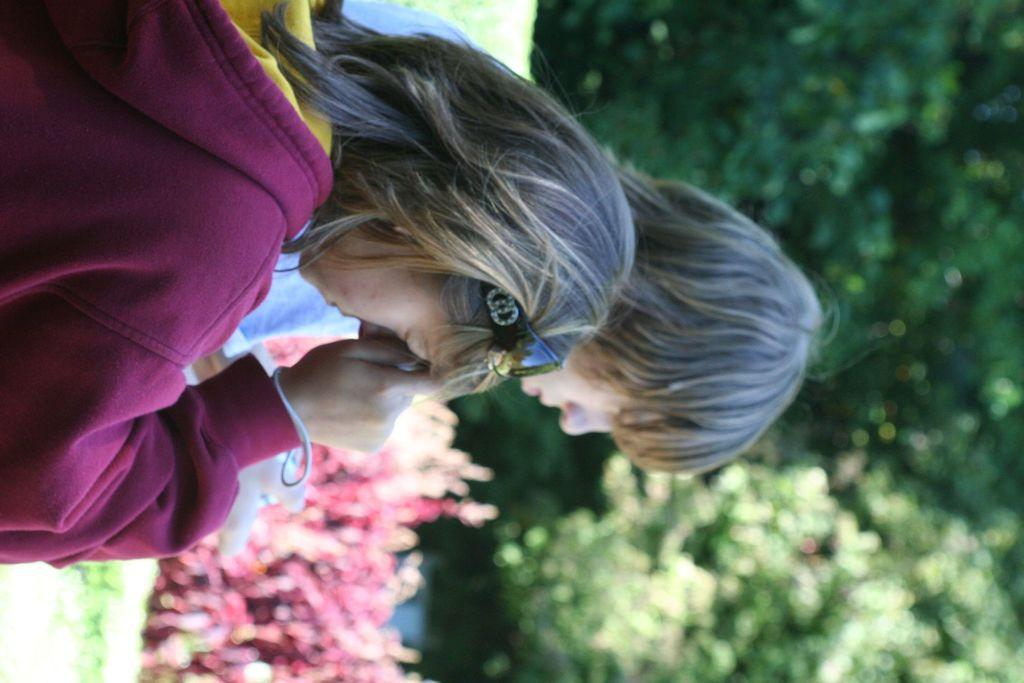Who or what can be seen in the image? There are people in the image. What can be seen in the background of the image? There is greenery in the background of the image. Are there any specific plants visible in the image? Yes, there appear to be red color plants in the image. How many celery stalks can be seen in the image? There is no celery present in the image. What color are the eyes of the people in the image? The provided facts do not mention the color of the people's eyes, so we cannot determine that information from the image. 